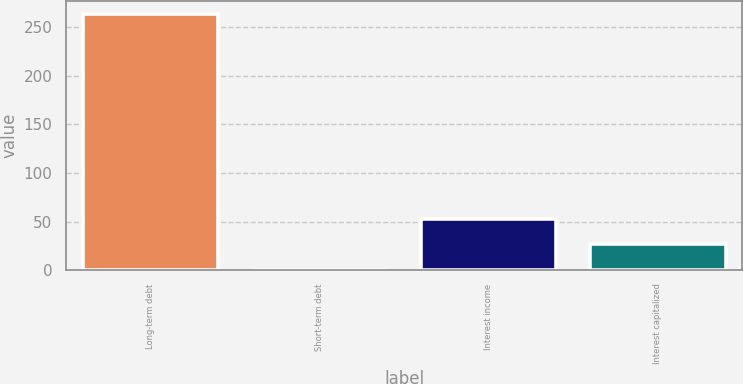Convert chart. <chart><loc_0><loc_0><loc_500><loc_500><bar_chart><fcel>Long-term debt<fcel>Short-term debt<fcel>Interest income<fcel>Interest capitalized<nl><fcel>263.5<fcel>0.4<fcel>53.02<fcel>26.71<nl></chart> 